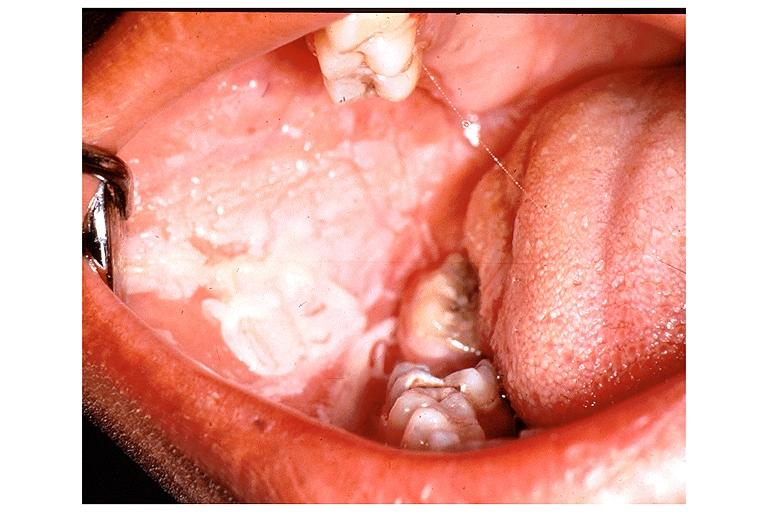where is this?
Answer the question using a single word or phrase. Oral 